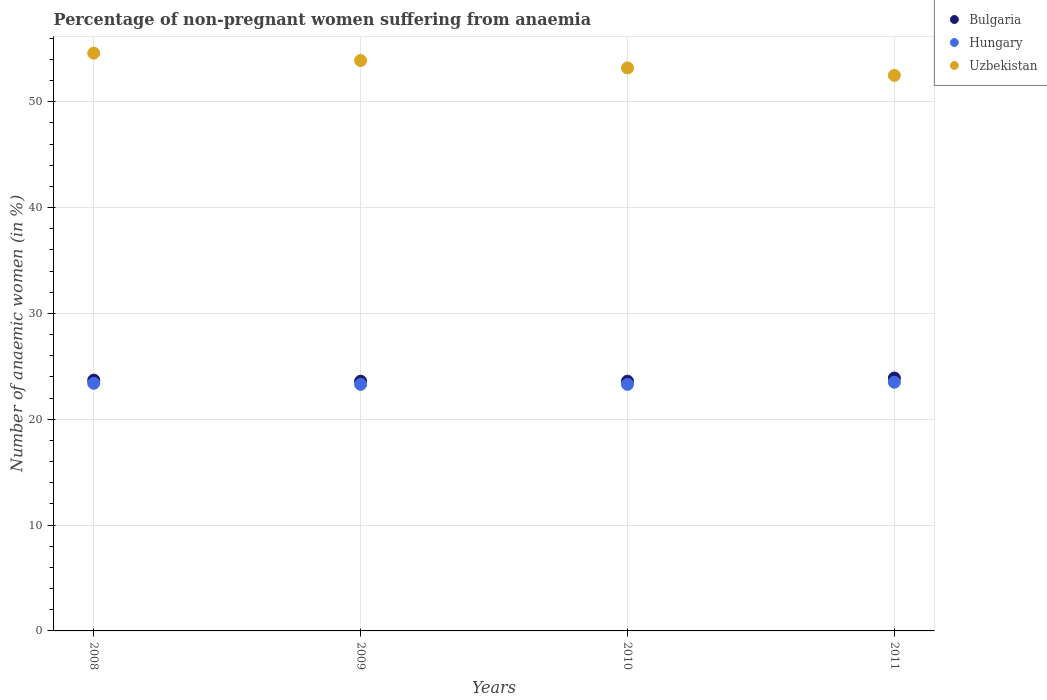Is the number of dotlines equal to the number of legend labels?
Keep it short and to the point. Yes. What is the percentage of non-pregnant women suffering from anaemia in Bulgaria in 2011?
Offer a very short reply. 23.9. Across all years, what is the minimum percentage of non-pregnant women suffering from anaemia in Bulgaria?
Keep it short and to the point. 23.6. In which year was the percentage of non-pregnant women suffering from anaemia in Bulgaria maximum?
Give a very brief answer. 2011. In which year was the percentage of non-pregnant women suffering from anaemia in Uzbekistan minimum?
Keep it short and to the point. 2011. What is the total percentage of non-pregnant women suffering from anaemia in Hungary in the graph?
Your response must be concise. 93.5. What is the difference between the percentage of non-pregnant women suffering from anaemia in Bulgaria in 2010 and that in 2011?
Offer a very short reply. -0.3. What is the difference between the percentage of non-pregnant women suffering from anaemia in Uzbekistan in 2009 and the percentage of non-pregnant women suffering from anaemia in Bulgaria in 2010?
Your answer should be very brief. 30.3. What is the average percentage of non-pregnant women suffering from anaemia in Bulgaria per year?
Provide a succinct answer. 23.7. In the year 2008, what is the difference between the percentage of non-pregnant women suffering from anaemia in Bulgaria and percentage of non-pregnant women suffering from anaemia in Hungary?
Make the answer very short. 0.3. In how many years, is the percentage of non-pregnant women suffering from anaemia in Uzbekistan greater than 48 %?
Offer a very short reply. 4. What is the ratio of the percentage of non-pregnant women suffering from anaemia in Hungary in 2008 to that in 2011?
Ensure brevity in your answer.  1. Is the percentage of non-pregnant women suffering from anaemia in Bulgaria in 2009 less than that in 2010?
Your answer should be compact. No. What is the difference between the highest and the second highest percentage of non-pregnant women suffering from anaemia in Uzbekistan?
Ensure brevity in your answer.  0.7. What is the difference between the highest and the lowest percentage of non-pregnant women suffering from anaemia in Uzbekistan?
Your answer should be compact. 2.1. In how many years, is the percentage of non-pregnant women suffering from anaemia in Hungary greater than the average percentage of non-pregnant women suffering from anaemia in Hungary taken over all years?
Offer a very short reply. 2. Is the sum of the percentage of non-pregnant women suffering from anaemia in Uzbekistan in 2009 and 2010 greater than the maximum percentage of non-pregnant women suffering from anaemia in Bulgaria across all years?
Provide a succinct answer. Yes. Is it the case that in every year, the sum of the percentage of non-pregnant women suffering from anaemia in Bulgaria and percentage of non-pregnant women suffering from anaemia in Uzbekistan  is greater than the percentage of non-pregnant women suffering from anaemia in Hungary?
Offer a terse response. Yes. Is the percentage of non-pregnant women suffering from anaemia in Uzbekistan strictly greater than the percentage of non-pregnant women suffering from anaemia in Bulgaria over the years?
Provide a succinct answer. Yes. Is the percentage of non-pregnant women suffering from anaemia in Uzbekistan strictly less than the percentage of non-pregnant women suffering from anaemia in Hungary over the years?
Make the answer very short. No. How many dotlines are there?
Provide a short and direct response. 3. How many years are there in the graph?
Provide a succinct answer. 4. What is the title of the graph?
Give a very brief answer. Percentage of non-pregnant women suffering from anaemia. Does "Euro area" appear as one of the legend labels in the graph?
Offer a very short reply. No. What is the label or title of the X-axis?
Keep it short and to the point. Years. What is the label or title of the Y-axis?
Your answer should be compact. Number of anaemic women (in %). What is the Number of anaemic women (in %) of Bulgaria in 2008?
Provide a short and direct response. 23.7. What is the Number of anaemic women (in %) in Hungary in 2008?
Give a very brief answer. 23.4. What is the Number of anaemic women (in %) of Uzbekistan in 2008?
Your answer should be very brief. 54.6. What is the Number of anaemic women (in %) in Bulgaria in 2009?
Offer a terse response. 23.6. What is the Number of anaemic women (in %) of Hungary in 2009?
Offer a very short reply. 23.3. What is the Number of anaemic women (in %) in Uzbekistan in 2009?
Ensure brevity in your answer.  53.9. What is the Number of anaemic women (in %) of Bulgaria in 2010?
Give a very brief answer. 23.6. What is the Number of anaemic women (in %) of Hungary in 2010?
Keep it short and to the point. 23.3. What is the Number of anaemic women (in %) of Uzbekistan in 2010?
Give a very brief answer. 53.2. What is the Number of anaemic women (in %) of Bulgaria in 2011?
Your response must be concise. 23.9. What is the Number of anaemic women (in %) of Hungary in 2011?
Make the answer very short. 23.5. What is the Number of anaemic women (in %) of Uzbekistan in 2011?
Make the answer very short. 52.5. Across all years, what is the maximum Number of anaemic women (in %) of Bulgaria?
Offer a very short reply. 23.9. Across all years, what is the maximum Number of anaemic women (in %) in Hungary?
Provide a succinct answer. 23.5. Across all years, what is the maximum Number of anaemic women (in %) of Uzbekistan?
Make the answer very short. 54.6. Across all years, what is the minimum Number of anaemic women (in %) of Bulgaria?
Offer a very short reply. 23.6. Across all years, what is the minimum Number of anaemic women (in %) of Hungary?
Keep it short and to the point. 23.3. Across all years, what is the minimum Number of anaemic women (in %) in Uzbekistan?
Your answer should be compact. 52.5. What is the total Number of anaemic women (in %) in Bulgaria in the graph?
Provide a succinct answer. 94.8. What is the total Number of anaemic women (in %) of Hungary in the graph?
Make the answer very short. 93.5. What is the total Number of anaemic women (in %) of Uzbekistan in the graph?
Provide a succinct answer. 214.2. What is the difference between the Number of anaemic women (in %) in Uzbekistan in 2008 and that in 2009?
Ensure brevity in your answer.  0.7. What is the difference between the Number of anaemic women (in %) of Bulgaria in 2008 and that in 2011?
Provide a short and direct response. -0.2. What is the difference between the Number of anaemic women (in %) in Hungary in 2008 and that in 2011?
Make the answer very short. -0.1. What is the difference between the Number of anaemic women (in %) in Bulgaria in 2009 and that in 2010?
Make the answer very short. 0. What is the difference between the Number of anaemic women (in %) in Hungary in 2009 and that in 2010?
Your response must be concise. 0. What is the difference between the Number of anaemic women (in %) in Uzbekistan in 2009 and that in 2010?
Provide a succinct answer. 0.7. What is the difference between the Number of anaemic women (in %) in Bulgaria in 2009 and that in 2011?
Offer a very short reply. -0.3. What is the difference between the Number of anaemic women (in %) of Uzbekistan in 2009 and that in 2011?
Ensure brevity in your answer.  1.4. What is the difference between the Number of anaemic women (in %) of Uzbekistan in 2010 and that in 2011?
Your answer should be compact. 0.7. What is the difference between the Number of anaemic women (in %) in Bulgaria in 2008 and the Number of anaemic women (in %) in Uzbekistan in 2009?
Give a very brief answer. -30.2. What is the difference between the Number of anaemic women (in %) in Hungary in 2008 and the Number of anaemic women (in %) in Uzbekistan in 2009?
Provide a succinct answer. -30.5. What is the difference between the Number of anaemic women (in %) of Bulgaria in 2008 and the Number of anaemic women (in %) of Hungary in 2010?
Make the answer very short. 0.4. What is the difference between the Number of anaemic women (in %) of Bulgaria in 2008 and the Number of anaemic women (in %) of Uzbekistan in 2010?
Your answer should be compact. -29.5. What is the difference between the Number of anaemic women (in %) in Hungary in 2008 and the Number of anaemic women (in %) in Uzbekistan in 2010?
Your answer should be compact. -29.8. What is the difference between the Number of anaemic women (in %) of Bulgaria in 2008 and the Number of anaemic women (in %) of Uzbekistan in 2011?
Your answer should be very brief. -28.8. What is the difference between the Number of anaemic women (in %) of Hungary in 2008 and the Number of anaemic women (in %) of Uzbekistan in 2011?
Your answer should be very brief. -29.1. What is the difference between the Number of anaemic women (in %) in Bulgaria in 2009 and the Number of anaemic women (in %) in Hungary in 2010?
Offer a terse response. 0.3. What is the difference between the Number of anaemic women (in %) of Bulgaria in 2009 and the Number of anaemic women (in %) of Uzbekistan in 2010?
Keep it short and to the point. -29.6. What is the difference between the Number of anaemic women (in %) in Hungary in 2009 and the Number of anaemic women (in %) in Uzbekistan in 2010?
Make the answer very short. -29.9. What is the difference between the Number of anaemic women (in %) of Bulgaria in 2009 and the Number of anaemic women (in %) of Uzbekistan in 2011?
Your response must be concise. -28.9. What is the difference between the Number of anaemic women (in %) of Hungary in 2009 and the Number of anaemic women (in %) of Uzbekistan in 2011?
Make the answer very short. -29.2. What is the difference between the Number of anaemic women (in %) in Bulgaria in 2010 and the Number of anaemic women (in %) in Uzbekistan in 2011?
Offer a very short reply. -28.9. What is the difference between the Number of anaemic women (in %) in Hungary in 2010 and the Number of anaemic women (in %) in Uzbekistan in 2011?
Offer a very short reply. -29.2. What is the average Number of anaemic women (in %) of Bulgaria per year?
Your response must be concise. 23.7. What is the average Number of anaemic women (in %) in Hungary per year?
Your answer should be very brief. 23.38. What is the average Number of anaemic women (in %) in Uzbekistan per year?
Ensure brevity in your answer.  53.55. In the year 2008, what is the difference between the Number of anaemic women (in %) in Bulgaria and Number of anaemic women (in %) in Hungary?
Provide a short and direct response. 0.3. In the year 2008, what is the difference between the Number of anaemic women (in %) of Bulgaria and Number of anaemic women (in %) of Uzbekistan?
Provide a succinct answer. -30.9. In the year 2008, what is the difference between the Number of anaemic women (in %) of Hungary and Number of anaemic women (in %) of Uzbekistan?
Your answer should be very brief. -31.2. In the year 2009, what is the difference between the Number of anaemic women (in %) in Bulgaria and Number of anaemic women (in %) in Hungary?
Make the answer very short. 0.3. In the year 2009, what is the difference between the Number of anaemic women (in %) in Bulgaria and Number of anaemic women (in %) in Uzbekistan?
Provide a short and direct response. -30.3. In the year 2009, what is the difference between the Number of anaemic women (in %) in Hungary and Number of anaemic women (in %) in Uzbekistan?
Offer a terse response. -30.6. In the year 2010, what is the difference between the Number of anaemic women (in %) in Bulgaria and Number of anaemic women (in %) in Hungary?
Your answer should be compact. 0.3. In the year 2010, what is the difference between the Number of anaemic women (in %) in Bulgaria and Number of anaemic women (in %) in Uzbekistan?
Make the answer very short. -29.6. In the year 2010, what is the difference between the Number of anaemic women (in %) of Hungary and Number of anaemic women (in %) of Uzbekistan?
Your answer should be very brief. -29.9. In the year 2011, what is the difference between the Number of anaemic women (in %) in Bulgaria and Number of anaemic women (in %) in Hungary?
Your answer should be compact. 0.4. In the year 2011, what is the difference between the Number of anaemic women (in %) of Bulgaria and Number of anaemic women (in %) of Uzbekistan?
Your response must be concise. -28.6. What is the ratio of the Number of anaemic women (in %) of Hungary in 2008 to that in 2009?
Provide a succinct answer. 1. What is the ratio of the Number of anaemic women (in %) in Uzbekistan in 2008 to that in 2009?
Provide a short and direct response. 1.01. What is the ratio of the Number of anaemic women (in %) of Bulgaria in 2008 to that in 2010?
Provide a short and direct response. 1. What is the ratio of the Number of anaemic women (in %) of Uzbekistan in 2008 to that in 2010?
Offer a terse response. 1.03. What is the ratio of the Number of anaemic women (in %) in Bulgaria in 2008 to that in 2011?
Offer a terse response. 0.99. What is the ratio of the Number of anaemic women (in %) in Hungary in 2008 to that in 2011?
Your response must be concise. 1. What is the ratio of the Number of anaemic women (in %) in Uzbekistan in 2008 to that in 2011?
Keep it short and to the point. 1.04. What is the ratio of the Number of anaemic women (in %) of Hungary in 2009 to that in 2010?
Your answer should be compact. 1. What is the ratio of the Number of anaemic women (in %) of Uzbekistan in 2009 to that in 2010?
Give a very brief answer. 1.01. What is the ratio of the Number of anaemic women (in %) of Bulgaria in 2009 to that in 2011?
Your response must be concise. 0.99. What is the ratio of the Number of anaemic women (in %) in Uzbekistan in 2009 to that in 2011?
Offer a very short reply. 1.03. What is the ratio of the Number of anaemic women (in %) of Bulgaria in 2010 to that in 2011?
Make the answer very short. 0.99. What is the ratio of the Number of anaemic women (in %) in Uzbekistan in 2010 to that in 2011?
Your answer should be very brief. 1.01. What is the difference between the highest and the second highest Number of anaemic women (in %) in Uzbekistan?
Keep it short and to the point. 0.7. What is the difference between the highest and the lowest Number of anaemic women (in %) of Uzbekistan?
Offer a very short reply. 2.1. 